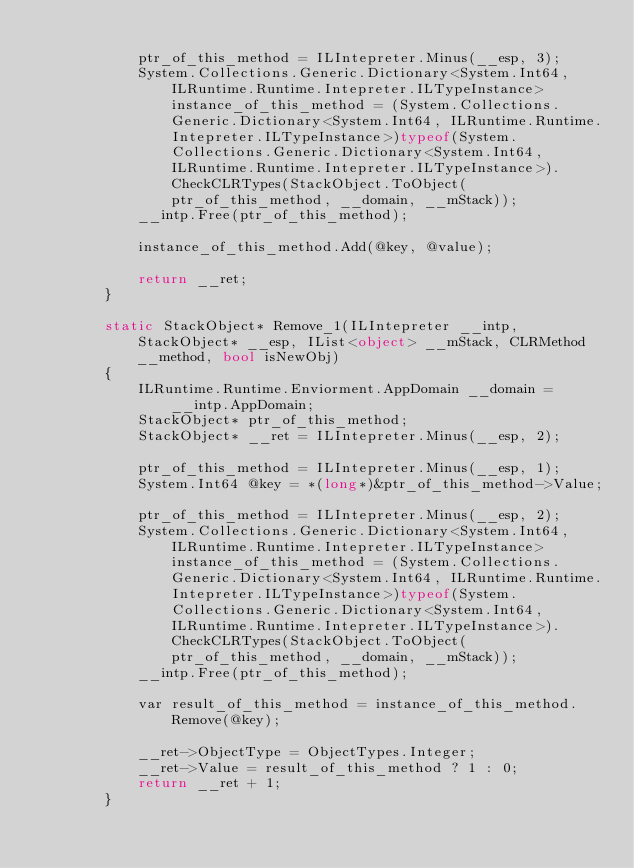<code> <loc_0><loc_0><loc_500><loc_500><_C#_>
            ptr_of_this_method = ILIntepreter.Minus(__esp, 3);
            System.Collections.Generic.Dictionary<System.Int64, ILRuntime.Runtime.Intepreter.ILTypeInstance> instance_of_this_method = (System.Collections.Generic.Dictionary<System.Int64, ILRuntime.Runtime.Intepreter.ILTypeInstance>)typeof(System.Collections.Generic.Dictionary<System.Int64, ILRuntime.Runtime.Intepreter.ILTypeInstance>).CheckCLRTypes(StackObject.ToObject(ptr_of_this_method, __domain, __mStack));
            __intp.Free(ptr_of_this_method);

            instance_of_this_method.Add(@key, @value);

            return __ret;
        }

        static StackObject* Remove_1(ILIntepreter __intp, StackObject* __esp, IList<object> __mStack, CLRMethod __method, bool isNewObj)
        {
            ILRuntime.Runtime.Enviorment.AppDomain __domain = __intp.AppDomain;
            StackObject* ptr_of_this_method;
            StackObject* __ret = ILIntepreter.Minus(__esp, 2);

            ptr_of_this_method = ILIntepreter.Minus(__esp, 1);
            System.Int64 @key = *(long*)&ptr_of_this_method->Value;

            ptr_of_this_method = ILIntepreter.Minus(__esp, 2);
            System.Collections.Generic.Dictionary<System.Int64, ILRuntime.Runtime.Intepreter.ILTypeInstance> instance_of_this_method = (System.Collections.Generic.Dictionary<System.Int64, ILRuntime.Runtime.Intepreter.ILTypeInstance>)typeof(System.Collections.Generic.Dictionary<System.Int64, ILRuntime.Runtime.Intepreter.ILTypeInstance>).CheckCLRTypes(StackObject.ToObject(ptr_of_this_method, __domain, __mStack));
            __intp.Free(ptr_of_this_method);

            var result_of_this_method = instance_of_this_method.Remove(@key);

            __ret->ObjectType = ObjectTypes.Integer;
            __ret->Value = result_of_this_method ? 1 : 0;
            return __ret + 1;
        }
</code> 